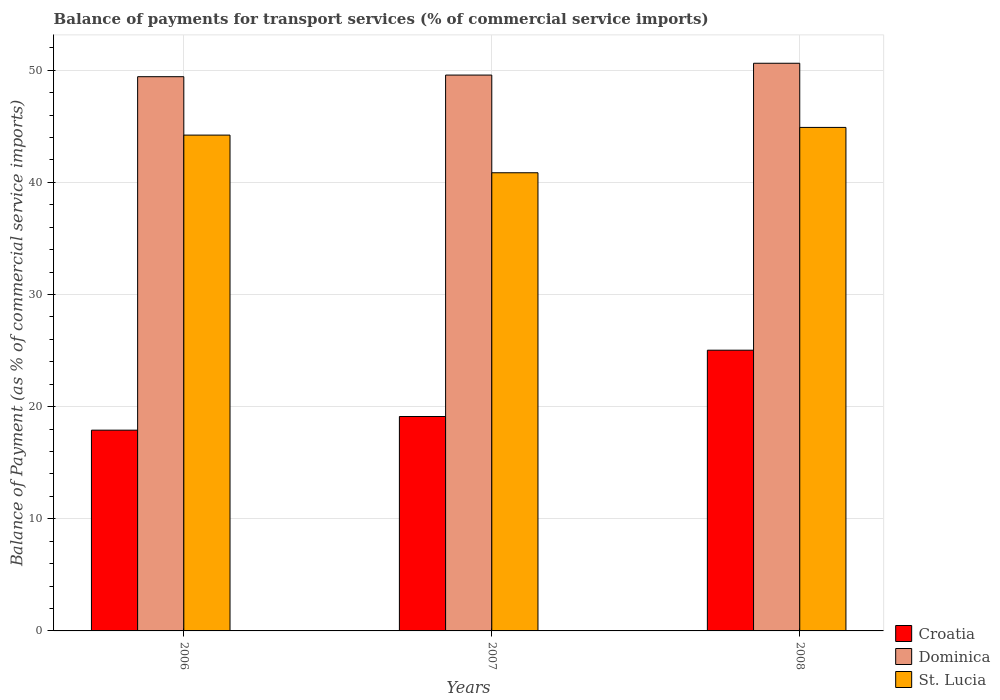How many bars are there on the 3rd tick from the left?
Make the answer very short. 3. What is the label of the 1st group of bars from the left?
Make the answer very short. 2006. In how many cases, is the number of bars for a given year not equal to the number of legend labels?
Your answer should be very brief. 0. What is the balance of payments for transport services in Dominica in 2008?
Your answer should be compact. 50.62. Across all years, what is the maximum balance of payments for transport services in Dominica?
Give a very brief answer. 50.62. Across all years, what is the minimum balance of payments for transport services in Dominica?
Give a very brief answer. 49.42. What is the total balance of payments for transport services in Croatia in the graph?
Provide a succinct answer. 62.05. What is the difference between the balance of payments for transport services in Croatia in 2006 and that in 2007?
Offer a terse response. -1.22. What is the difference between the balance of payments for transport services in St. Lucia in 2007 and the balance of payments for transport services in Dominica in 2006?
Your response must be concise. -8.57. What is the average balance of payments for transport services in Croatia per year?
Your answer should be compact. 20.68. In the year 2006, what is the difference between the balance of payments for transport services in St. Lucia and balance of payments for transport services in Croatia?
Provide a succinct answer. 26.31. In how many years, is the balance of payments for transport services in St. Lucia greater than 2 %?
Offer a very short reply. 3. What is the ratio of the balance of payments for transport services in Croatia in 2006 to that in 2008?
Provide a succinct answer. 0.72. Is the balance of payments for transport services in Dominica in 2006 less than that in 2008?
Your response must be concise. Yes. What is the difference between the highest and the second highest balance of payments for transport services in Croatia?
Your response must be concise. 5.91. What is the difference between the highest and the lowest balance of payments for transport services in Dominica?
Your response must be concise. 1.2. Is the sum of the balance of payments for transport services in Croatia in 2006 and 2007 greater than the maximum balance of payments for transport services in Dominica across all years?
Provide a short and direct response. No. What does the 1st bar from the left in 2006 represents?
Offer a very short reply. Croatia. What does the 1st bar from the right in 2008 represents?
Provide a short and direct response. St. Lucia. Is it the case that in every year, the sum of the balance of payments for transport services in Croatia and balance of payments for transport services in St. Lucia is greater than the balance of payments for transport services in Dominica?
Ensure brevity in your answer.  Yes. How many bars are there?
Provide a succinct answer. 9. What is the difference between two consecutive major ticks on the Y-axis?
Give a very brief answer. 10. Where does the legend appear in the graph?
Give a very brief answer. Bottom right. What is the title of the graph?
Your response must be concise. Balance of payments for transport services (% of commercial service imports). What is the label or title of the Y-axis?
Your response must be concise. Balance of Payment (as % of commercial service imports). What is the Balance of Payment (as % of commercial service imports) in Croatia in 2006?
Keep it short and to the point. 17.9. What is the Balance of Payment (as % of commercial service imports) in Dominica in 2006?
Provide a succinct answer. 49.42. What is the Balance of Payment (as % of commercial service imports) of St. Lucia in 2006?
Ensure brevity in your answer.  44.21. What is the Balance of Payment (as % of commercial service imports) of Croatia in 2007?
Give a very brief answer. 19.12. What is the Balance of Payment (as % of commercial service imports) of Dominica in 2007?
Give a very brief answer. 49.57. What is the Balance of Payment (as % of commercial service imports) in St. Lucia in 2007?
Your answer should be very brief. 40.85. What is the Balance of Payment (as % of commercial service imports) in Croatia in 2008?
Your response must be concise. 25.03. What is the Balance of Payment (as % of commercial service imports) of Dominica in 2008?
Ensure brevity in your answer.  50.62. What is the Balance of Payment (as % of commercial service imports) of St. Lucia in 2008?
Keep it short and to the point. 44.9. Across all years, what is the maximum Balance of Payment (as % of commercial service imports) in Croatia?
Ensure brevity in your answer.  25.03. Across all years, what is the maximum Balance of Payment (as % of commercial service imports) of Dominica?
Your response must be concise. 50.62. Across all years, what is the maximum Balance of Payment (as % of commercial service imports) in St. Lucia?
Your answer should be compact. 44.9. Across all years, what is the minimum Balance of Payment (as % of commercial service imports) of Croatia?
Give a very brief answer. 17.9. Across all years, what is the minimum Balance of Payment (as % of commercial service imports) of Dominica?
Make the answer very short. 49.42. Across all years, what is the minimum Balance of Payment (as % of commercial service imports) of St. Lucia?
Your answer should be very brief. 40.85. What is the total Balance of Payment (as % of commercial service imports) of Croatia in the graph?
Provide a short and direct response. 62.05. What is the total Balance of Payment (as % of commercial service imports) of Dominica in the graph?
Provide a succinct answer. 149.6. What is the total Balance of Payment (as % of commercial service imports) in St. Lucia in the graph?
Ensure brevity in your answer.  129.96. What is the difference between the Balance of Payment (as % of commercial service imports) of Croatia in 2006 and that in 2007?
Give a very brief answer. -1.22. What is the difference between the Balance of Payment (as % of commercial service imports) in Dominica in 2006 and that in 2007?
Offer a terse response. -0.15. What is the difference between the Balance of Payment (as % of commercial service imports) in St. Lucia in 2006 and that in 2007?
Offer a very short reply. 3.36. What is the difference between the Balance of Payment (as % of commercial service imports) in Croatia in 2006 and that in 2008?
Offer a terse response. -7.13. What is the difference between the Balance of Payment (as % of commercial service imports) in Dominica in 2006 and that in 2008?
Provide a succinct answer. -1.2. What is the difference between the Balance of Payment (as % of commercial service imports) of St. Lucia in 2006 and that in 2008?
Provide a succinct answer. -0.69. What is the difference between the Balance of Payment (as % of commercial service imports) of Croatia in 2007 and that in 2008?
Ensure brevity in your answer.  -5.91. What is the difference between the Balance of Payment (as % of commercial service imports) in Dominica in 2007 and that in 2008?
Ensure brevity in your answer.  -1.05. What is the difference between the Balance of Payment (as % of commercial service imports) of St. Lucia in 2007 and that in 2008?
Offer a very short reply. -4.04. What is the difference between the Balance of Payment (as % of commercial service imports) in Croatia in 2006 and the Balance of Payment (as % of commercial service imports) in Dominica in 2007?
Offer a very short reply. -31.66. What is the difference between the Balance of Payment (as % of commercial service imports) in Croatia in 2006 and the Balance of Payment (as % of commercial service imports) in St. Lucia in 2007?
Offer a terse response. -22.95. What is the difference between the Balance of Payment (as % of commercial service imports) of Dominica in 2006 and the Balance of Payment (as % of commercial service imports) of St. Lucia in 2007?
Your answer should be compact. 8.57. What is the difference between the Balance of Payment (as % of commercial service imports) in Croatia in 2006 and the Balance of Payment (as % of commercial service imports) in Dominica in 2008?
Provide a short and direct response. -32.72. What is the difference between the Balance of Payment (as % of commercial service imports) of Croatia in 2006 and the Balance of Payment (as % of commercial service imports) of St. Lucia in 2008?
Make the answer very short. -27. What is the difference between the Balance of Payment (as % of commercial service imports) in Dominica in 2006 and the Balance of Payment (as % of commercial service imports) in St. Lucia in 2008?
Provide a short and direct response. 4.52. What is the difference between the Balance of Payment (as % of commercial service imports) of Croatia in 2007 and the Balance of Payment (as % of commercial service imports) of Dominica in 2008?
Keep it short and to the point. -31.5. What is the difference between the Balance of Payment (as % of commercial service imports) of Croatia in 2007 and the Balance of Payment (as % of commercial service imports) of St. Lucia in 2008?
Make the answer very short. -25.78. What is the difference between the Balance of Payment (as % of commercial service imports) of Dominica in 2007 and the Balance of Payment (as % of commercial service imports) of St. Lucia in 2008?
Offer a terse response. 4.67. What is the average Balance of Payment (as % of commercial service imports) in Croatia per year?
Provide a succinct answer. 20.68. What is the average Balance of Payment (as % of commercial service imports) in Dominica per year?
Offer a very short reply. 49.87. What is the average Balance of Payment (as % of commercial service imports) in St. Lucia per year?
Provide a short and direct response. 43.32. In the year 2006, what is the difference between the Balance of Payment (as % of commercial service imports) in Croatia and Balance of Payment (as % of commercial service imports) in Dominica?
Ensure brevity in your answer.  -31.52. In the year 2006, what is the difference between the Balance of Payment (as % of commercial service imports) in Croatia and Balance of Payment (as % of commercial service imports) in St. Lucia?
Your answer should be very brief. -26.31. In the year 2006, what is the difference between the Balance of Payment (as % of commercial service imports) in Dominica and Balance of Payment (as % of commercial service imports) in St. Lucia?
Your answer should be very brief. 5.21. In the year 2007, what is the difference between the Balance of Payment (as % of commercial service imports) in Croatia and Balance of Payment (as % of commercial service imports) in Dominica?
Provide a succinct answer. -30.45. In the year 2007, what is the difference between the Balance of Payment (as % of commercial service imports) in Croatia and Balance of Payment (as % of commercial service imports) in St. Lucia?
Offer a terse response. -21.73. In the year 2007, what is the difference between the Balance of Payment (as % of commercial service imports) of Dominica and Balance of Payment (as % of commercial service imports) of St. Lucia?
Keep it short and to the point. 8.71. In the year 2008, what is the difference between the Balance of Payment (as % of commercial service imports) of Croatia and Balance of Payment (as % of commercial service imports) of Dominica?
Your response must be concise. -25.59. In the year 2008, what is the difference between the Balance of Payment (as % of commercial service imports) in Croatia and Balance of Payment (as % of commercial service imports) in St. Lucia?
Give a very brief answer. -19.86. In the year 2008, what is the difference between the Balance of Payment (as % of commercial service imports) of Dominica and Balance of Payment (as % of commercial service imports) of St. Lucia?
Make the answer very short. 5.72. What is the ratio of the Balance of Payment (as % of commercial service imports) of Croatia in 2006 to that in 2007?
Your answer should be compact. 0.94. What is the ratio of the Balance of Payment (as % of commercial service imports) of St. Lucia in 2006 to that in 2007?
Your answer should be very brief. 1.08. What is the ratio of the Balance of Payment (as % of commercial service imports) in Croatia in 2006 to that in 2008?
Offer a terse response. 0.72. What is the ratio of the Balance of Payment (as % of commercial service imports) in Dominica in 2006 to that in 2008?
Give a very brief answer. 0.98. What is the ratio of the Balance of Payment (as % of commercial service imports) in St. Lucia in 2006 to that in 2008?
Make the answer very short. 0.98. What is the ratio of the Balance of Payment (as % of commercial service imports) in Croatia in 2007 to that in 2008?
Your answer should be compact. 0.76. What is the ratio of the Balance of Payment (as % of commercial service imports) of Dominica in 2007 to that in 2008?
Your answer should be compact. 0.98. What is the ratio of the Balance of Payment (as % of commercial service imports) of St. Lucia in 2007 to that in 2008?
Ensure brevity in your answer.  0.91. What is the difference between the highest and the second highest Balance of Payment (as % of commercial service imports) in Croatia?
Your answer should be compact. 5.91. What is the difference between the highest and the second highest Balance of Payment (as % of commercial service imports) in Dominica?
Your response must be concise. 1.05. What is the difference between the highest and the second highest Balance of Payment (as % of commercial service imports) in St. Lucia?
Offer a terse response. 0.69. What is the difference between the highest and the lowest Balance of Payment (as % of commercial service imports) in Croatia?
Your answer should be compact. 7.13. What is the difference between the highest and the lowest Balance of Payment (as % of commercial service imports) of Dominica?
Ensure brevity in your answer.  1.2. What is the difference between the highest and the lowest Balance of Payment (as % of commercial service imports) of St. Lucia?
Make the answer very short. 4.04. 